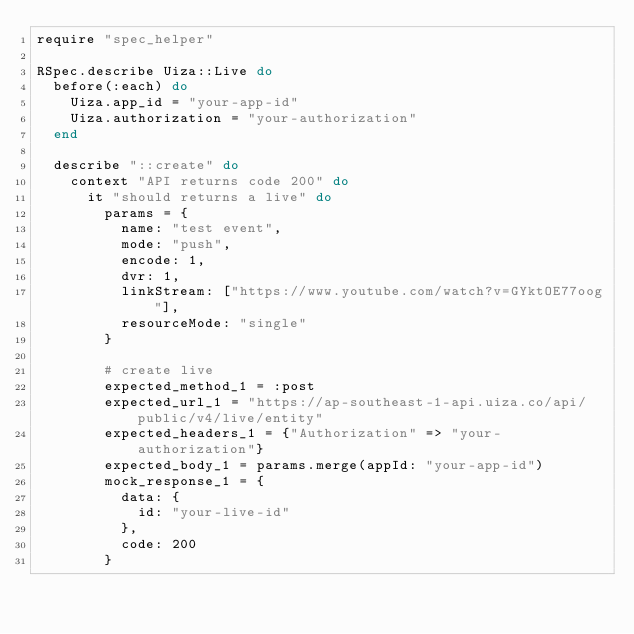<code> <loc_0><loc_0><loc_500><loc_500><_Ruby_>require "spec_helper"

RSpec.describe Uiza::Live do
  before(:each) do
    Uiza.app_id = "your-app-id"
    Uiza.authorization = "your-authorization"
  end

  describe "::create" do
    context "API returns code 200" do
      it "should returns a live" do
        params = {
          name: "test event",
          mode: "push",
          encode: 1,
          dvr: 1,
          linkStream: ["https://www.youtube.com/watch?v=GYktOE77oog"],
          resourceMode: "single"
        }

        # create live
        expected_method_1 = :post
        expected_url_1 = "https://ap-southeast-1-api.uiza.co/api/public/v4/live/entity"
        expected_headers_1 = {"Authorization" => "your-authorization"}
        expected_body_1 = params.merge(appId: "your-app-id")
        mock_response_1 = {
          data: {
            id: "your-live-id"
          },
          code: 200
        }
</code> 